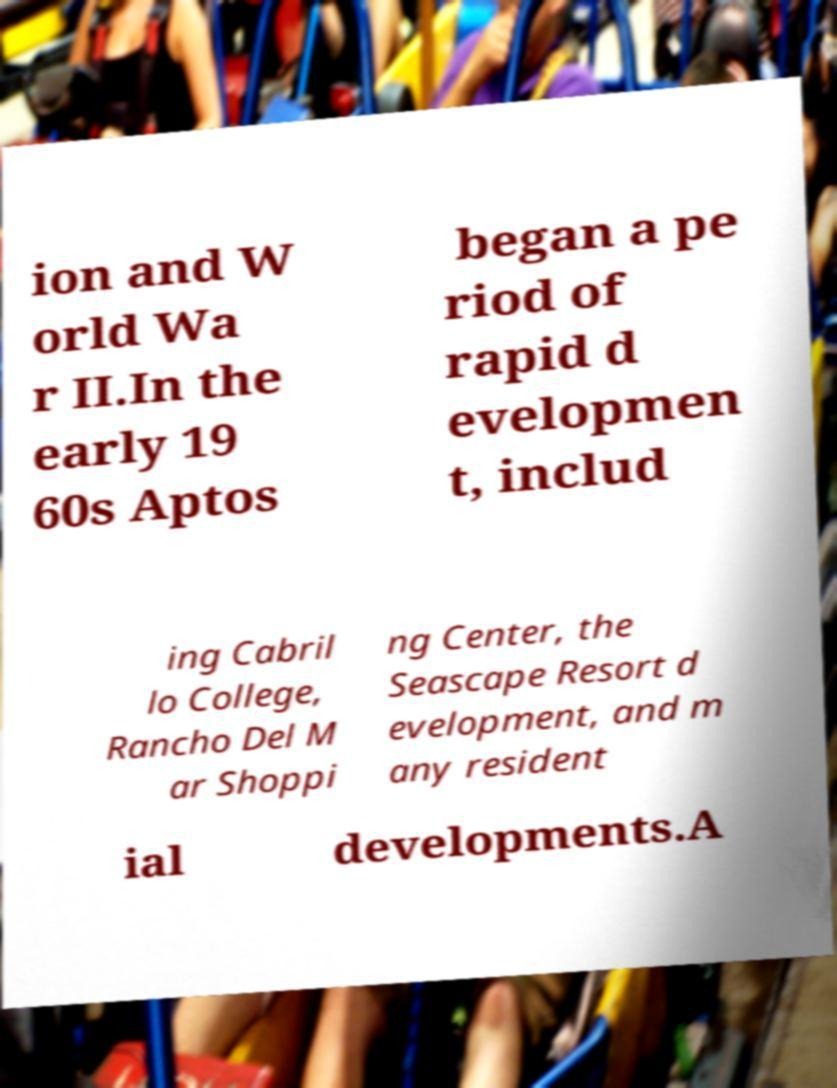Could you assist in decoding the text presented in this image and type it out clearly? ion and W orld Wa r II.In the early 19 60s Aptos began a pe riod of rapid d evelopmen t, includ ing Cabril lo College, Rancho Del M ar Shoppi ng Center, the Seascape Resort d evelopment, and m any resident ial developments.A 